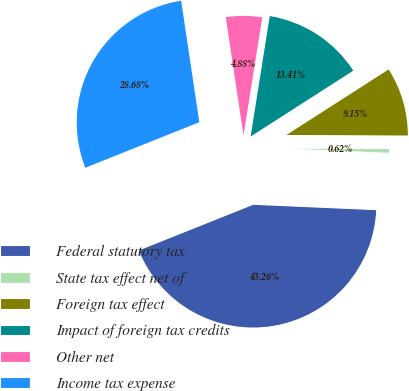<chart> <loc_0><loc_0><loc_500><loc_500><pie_chart><fcel>Federal statutory tax<fcel>State tax effect net of<fcel>Foreign tax effect<fcel>Impact of foreign tax credits<fcel>Other net<fcel>Income tax expense<nl><fcel>43.26%<fcel>0.62%<fcel>9.15%<fcel>13.41%<fcel>4.88%<fcel>28.68%<nl></chart> 